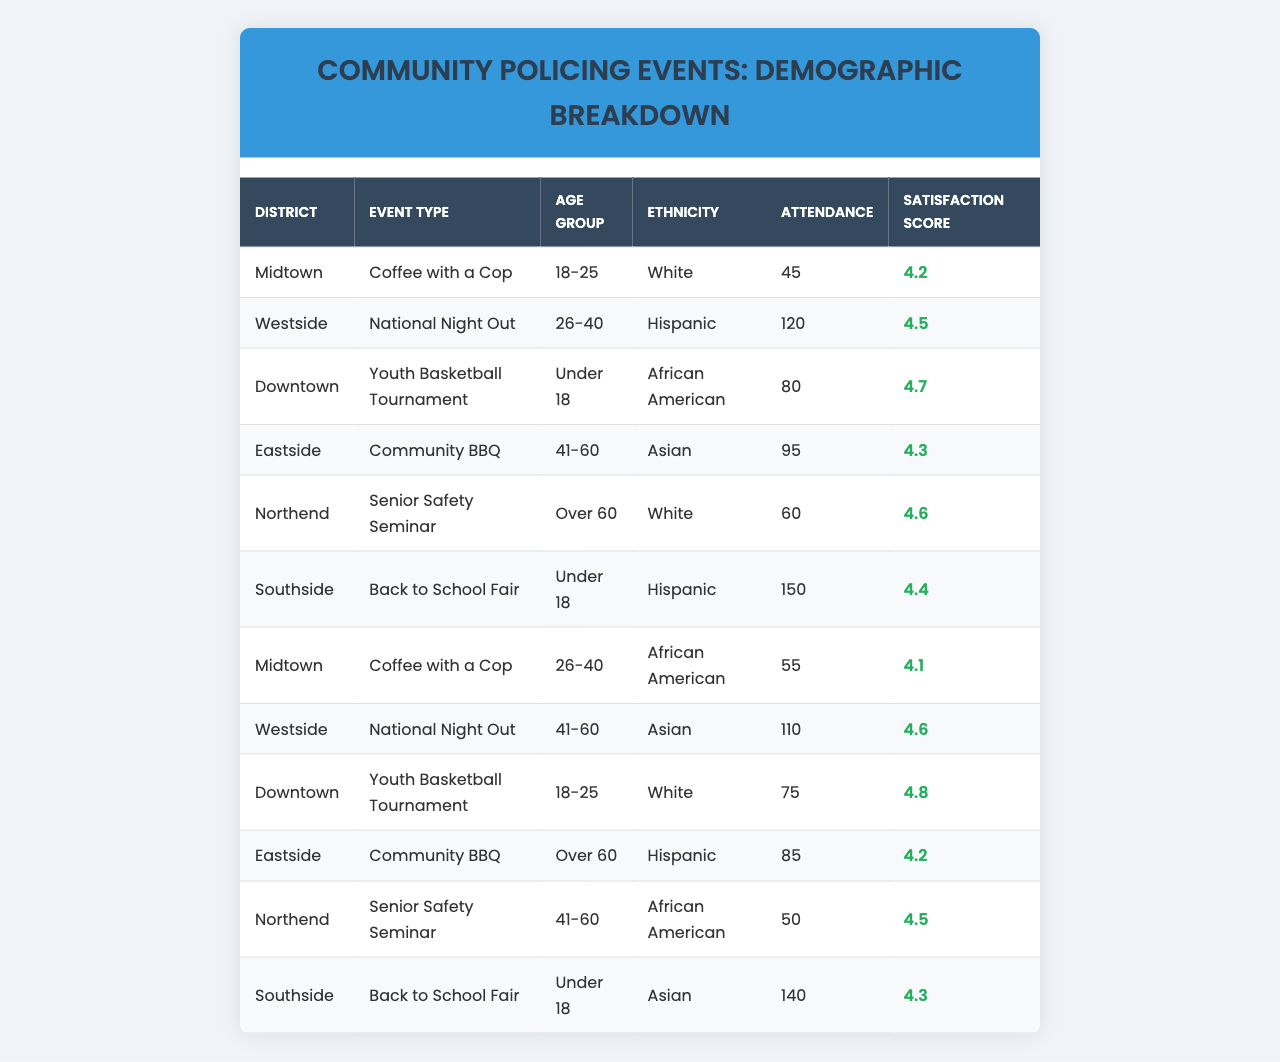What is the highest attendance recorded for any event? Looking at the attendance values listed in the table, the highest value is 150, which corresponds to the 'Back to School Fair' in the 'Southside' district.
Answer: 150 Which event had the highest satisfaction score? The satisfaction scores show that the 'Youth Basketball Tournament' in the 'Downtown' district has the highest satisfaction score of 4.8.
Answer: 4.8 How many attendees participated in 'Coffee with a Cop' events? Summing the attendance for both 'Coffee with a Cop' events, we find 45 + 55 = 100 attendees.
Answer: 100 What is the average satisfaction score for events in the 'Westside' district? The scores for events in 'Westside' are 4.5 and 4.6. To find the average, we sum them (4.5 + 4.6 = 9.1) and divide by 2, which gives us an average of 4.55.
Answer: 4.55 Which age group attended the most events across all districts? By counting the occurrence of each age group in the table, 'Under 18' and '41-60' are represented in four events each, more than any other age group.
Answer: Under 18 and 41-60 Is there any event where attendees were all over 60 years old? Checking the age groups for each event reveals that no event has exclusively attendees over 60, so the answer is no.
Answer: No How does the attendance at community BBQs compare between the 'Midtown' and 'Downtown' districts? The attendance for 'Community BBQ' in 'Midtown' is 95 and in 'Downtown' is 85. This means 'Midtown' had 10 more attendees than 'Downtown'.
Answer: Midtown had 10 more attendees than Downtown What is the total attendance for events targeting those aged 18-25? The events for the age group 18-25 are 'Youth Basketball Tournament' in 'Downtown' (75 attendees) and 'Coffee with a Cop' in 'Midtown' (45 attendees). Adding these gives 75 + 45 = 120 total attendees.
Answer: 120 How many events had an attendance of 100 or more? By checking the attendance numbers, we find that four events had 100 or more attendees: 'National Night Out' (120), 'Back to School Fair' (150), 'Senior Safety Seminar' (140), and 'Coffee with a Cop' (55).
Answer: 4 What ethnic group had the highest level of attendance, and how many attended? Reviewing ethnicities and their corresponding attendance, the 'Hispanic' group in Southside had the highest attendance with 150 attendees at the 'Back to School Fair'.
Answer: Hispanic, 150 